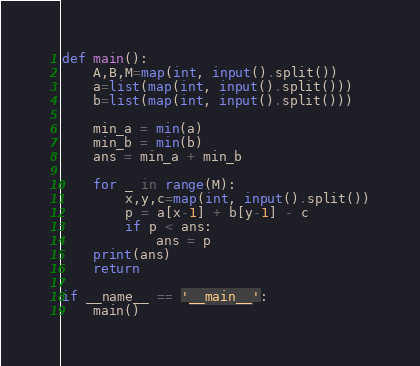<code> <loc_0><loc_0><loc_500><loc_500><_Python_>def main():
    A,B,M=map(int, input().split())
    a=list(map(int, input().split()))
    b=list(map(int, input().split()))
    
    min_a = min(a)
    min_b = min(b)
    ans = min_a + min_b

    for _ in range(M):
        x,y,c=map(int, input().split())
        p = a[x-1] + b[y-1] - c
        if p < ans:
            ans = p
    print(ans)
    return

if __name__ == '__main__':
    main()</code> 